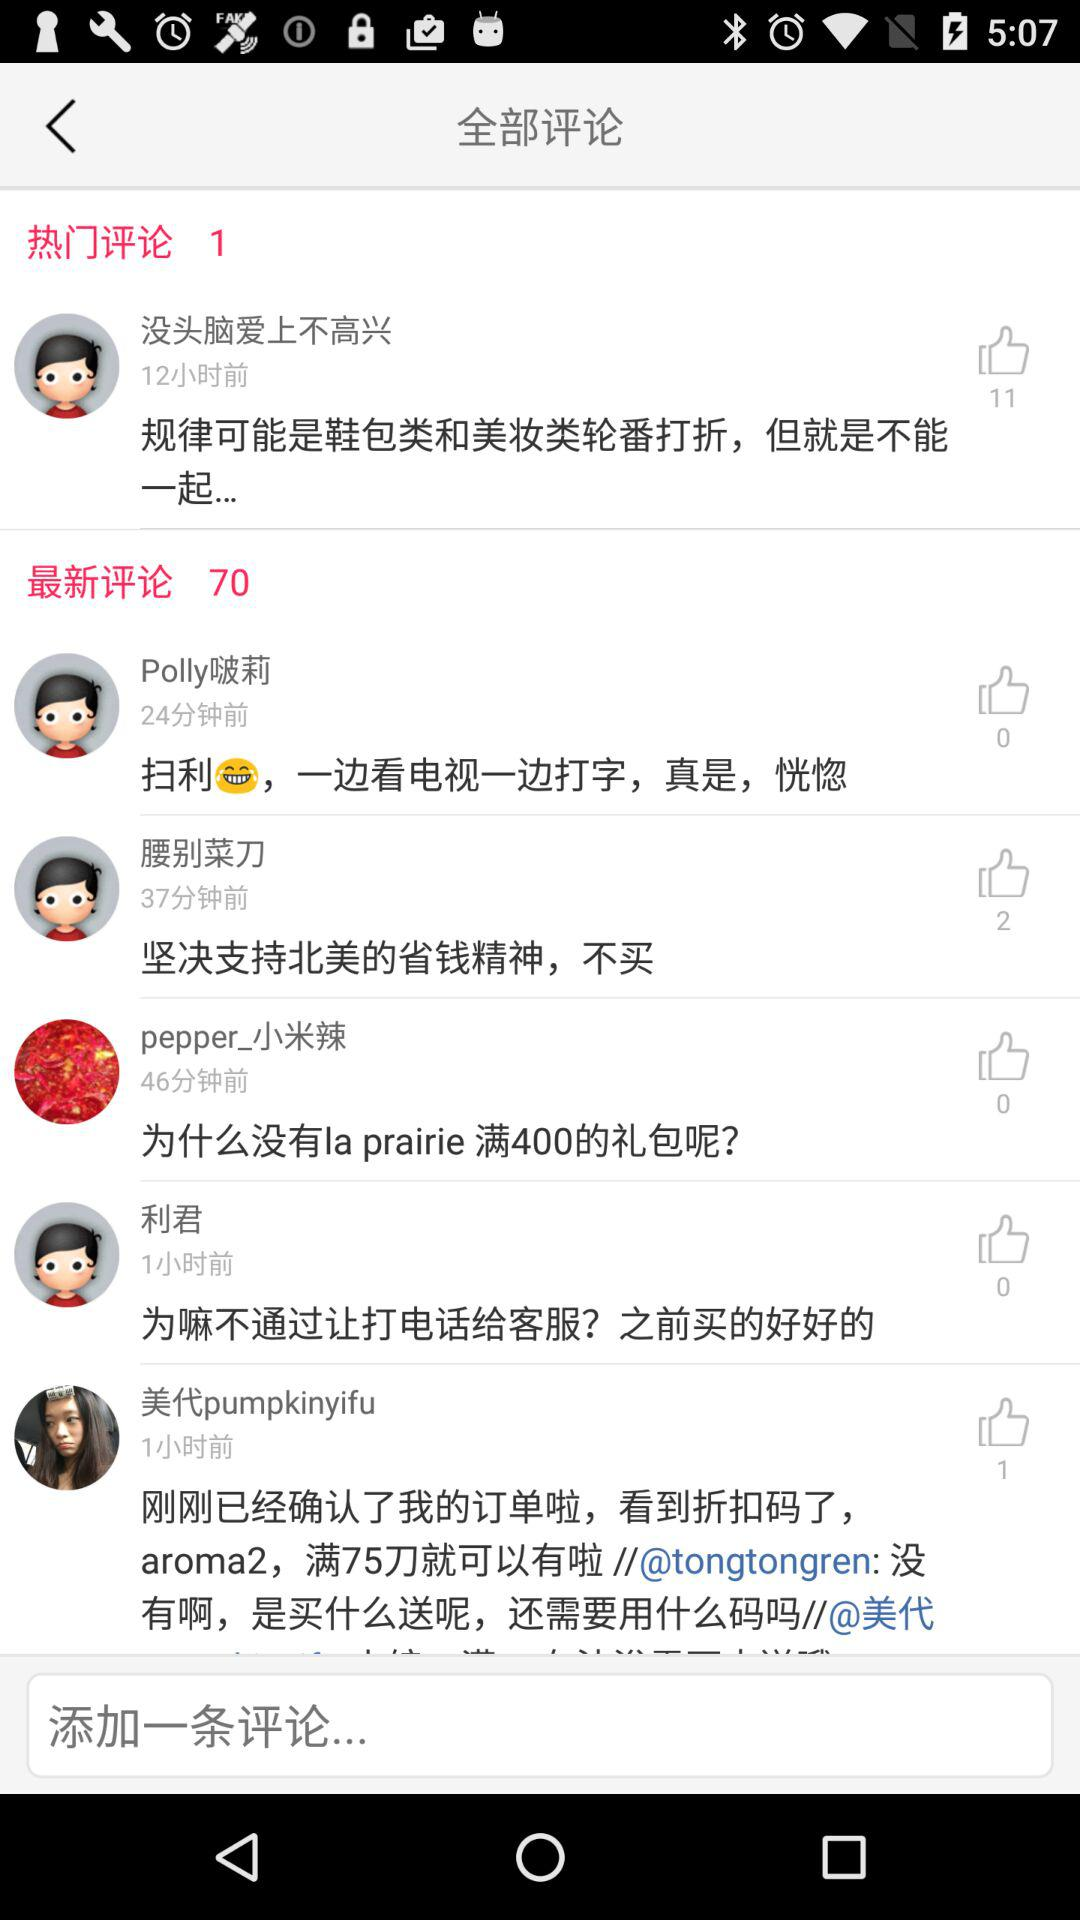How many more thumbs up does the first comment have than the second comment?
Answer the question using a single word or phrase. 11 